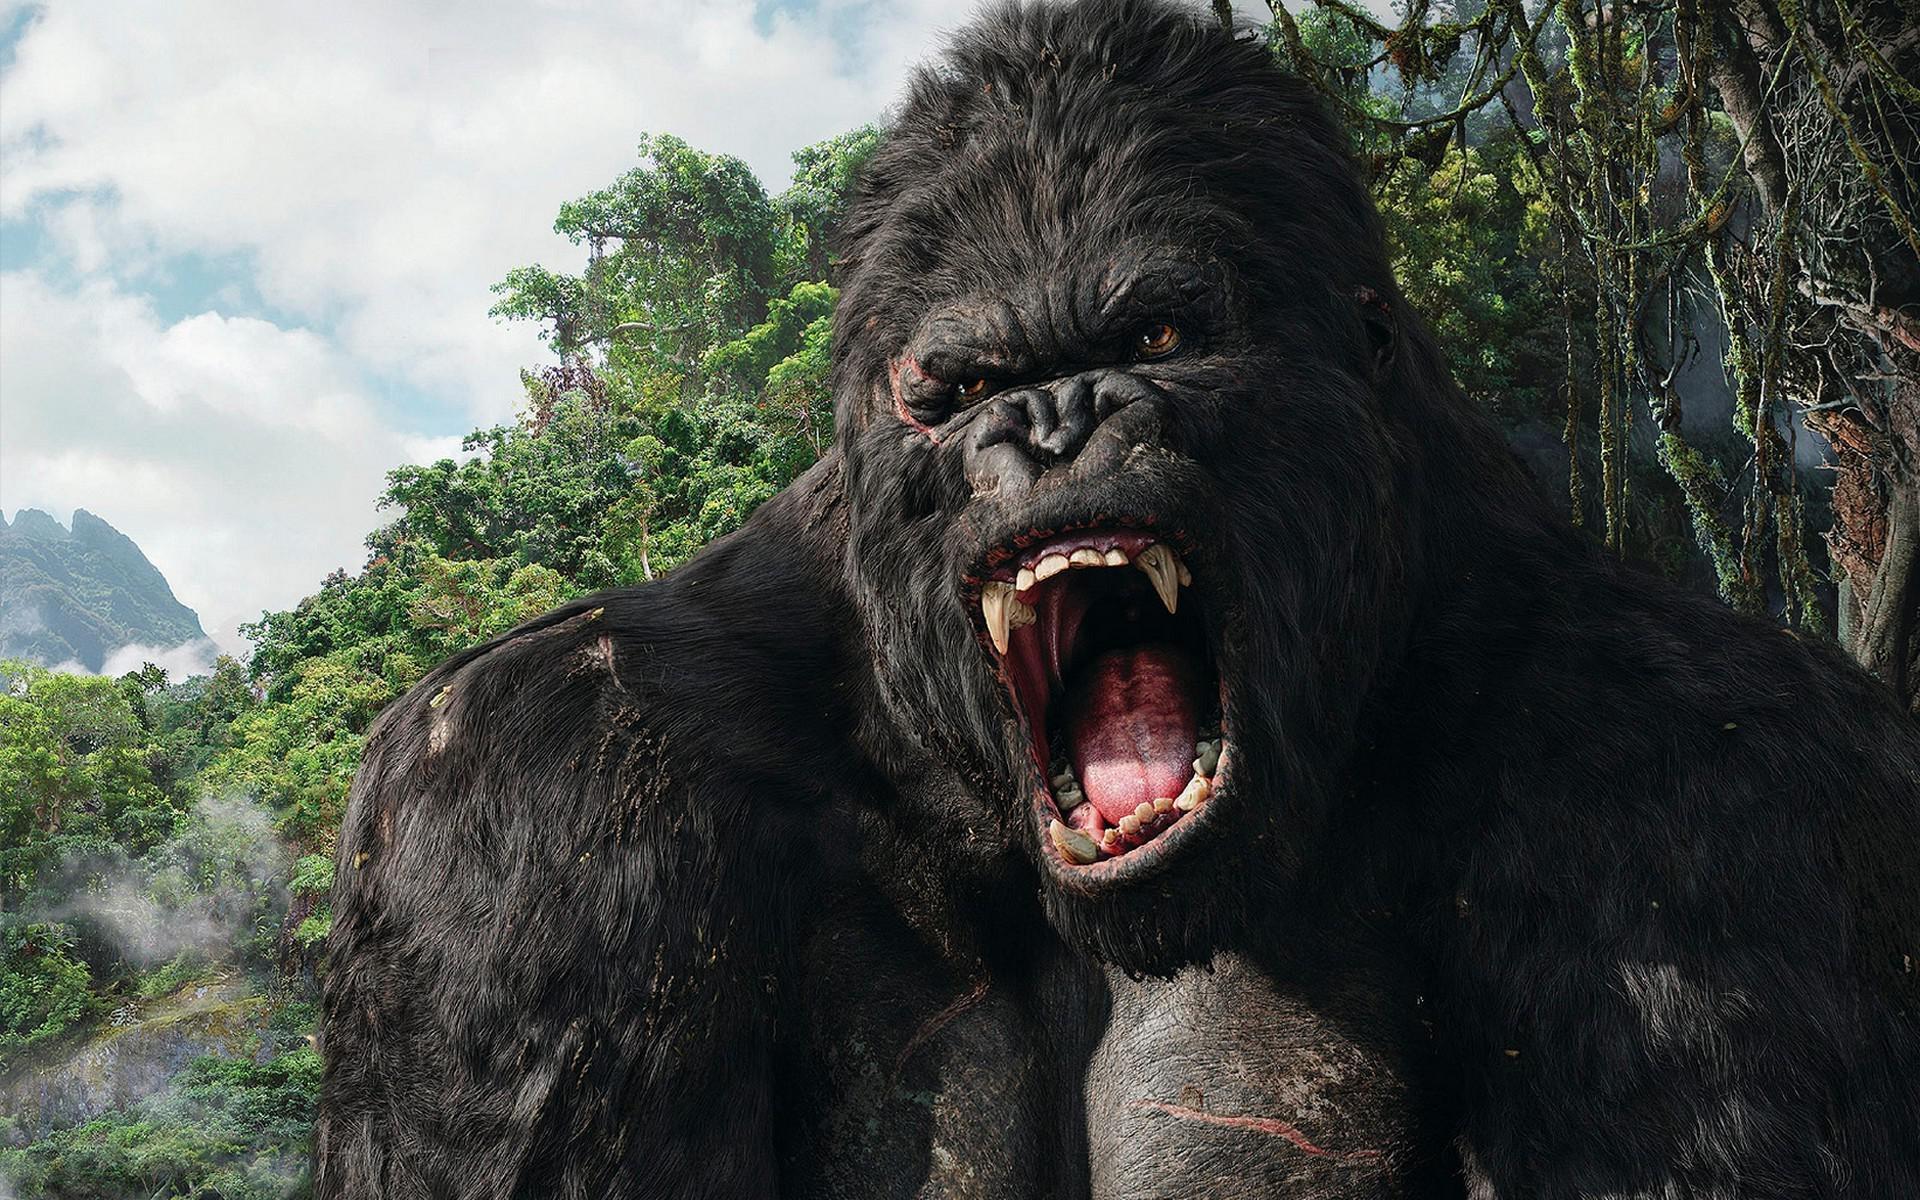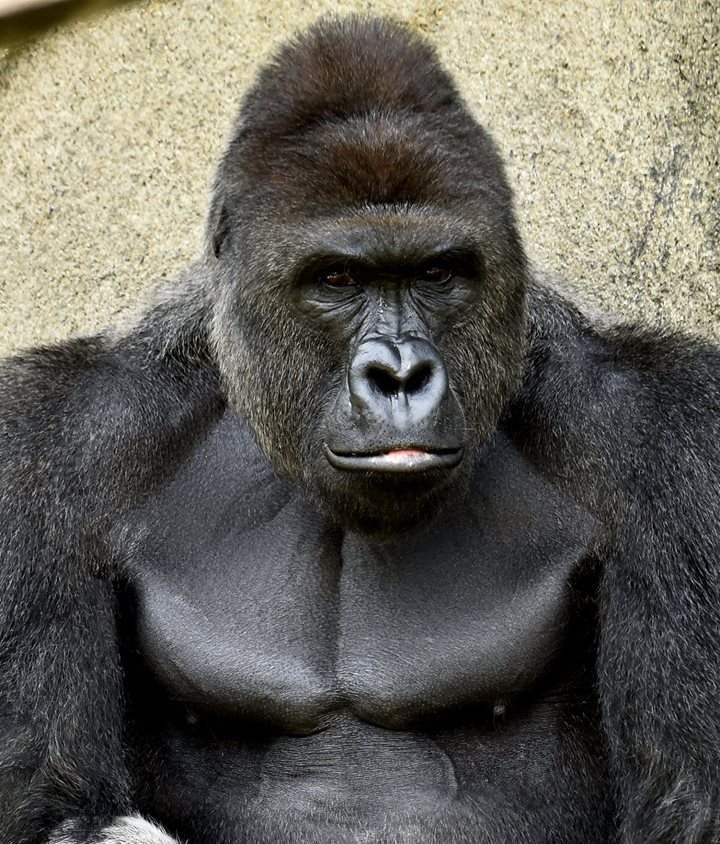The first image is the image on the left, the second image is the image on the right. Analyze the images presented: Is the assertion "One image shows one ape, which is in a rear-facing on-all-fours pose, and the other image shows a gorilla baring its fangs." valid? Answer yes or no. No. The first image is the image on the left, the second image is the image on the right. Assess this claim about the two images: "The ape in the image on the left is baring its teeth.". Correct or not? Answer yes or no. Yes. 